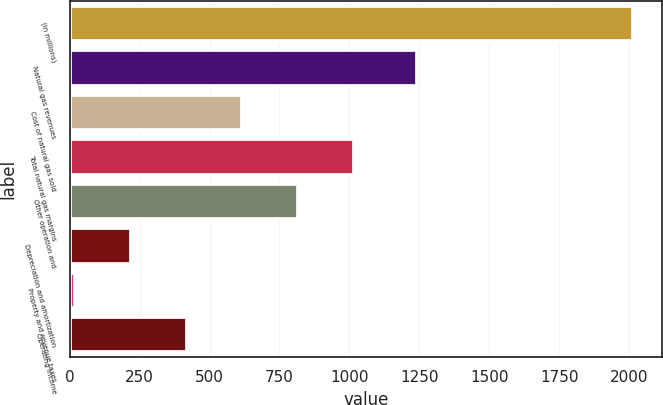Convert chart. <chart><loc_0><loc_0><loc_500><loc_500><bar_chart><fcel>(in millions)<fcel>Natural gas revenues<fcel>Cost of natural gas sold<fcel>Total natural gas margins<fcel>Other operation and<fcel>Depreciation and amortization<fcel>Property and revenue taxes<fcel>Operating income<nl><fcel>2016<fcel>1242.2<fcel>617.61<fcel>1017.15<fcel>817.38<fcel>218.07<fcel>18.3<fcel>417.84<nl></chart> 